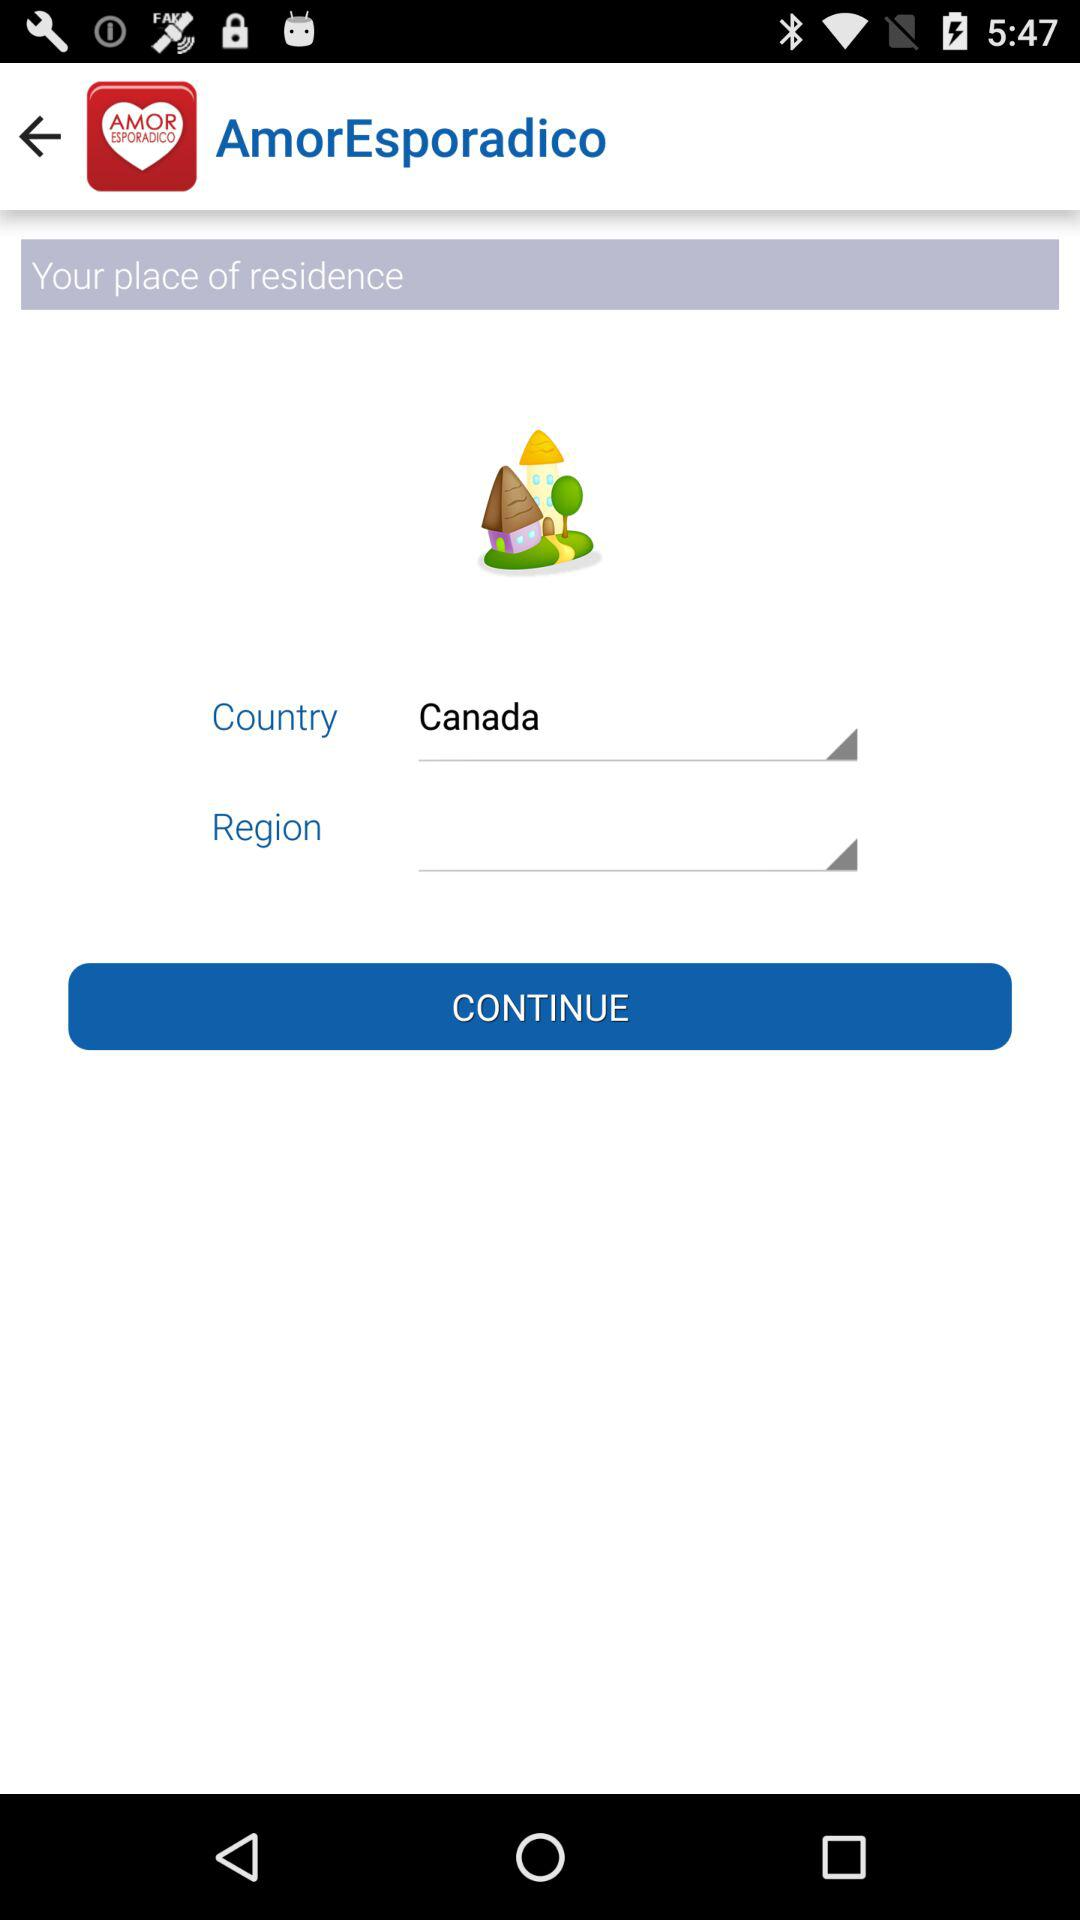How many text inputs are there for the location?
Answer the question using a single word or phrase. 2 